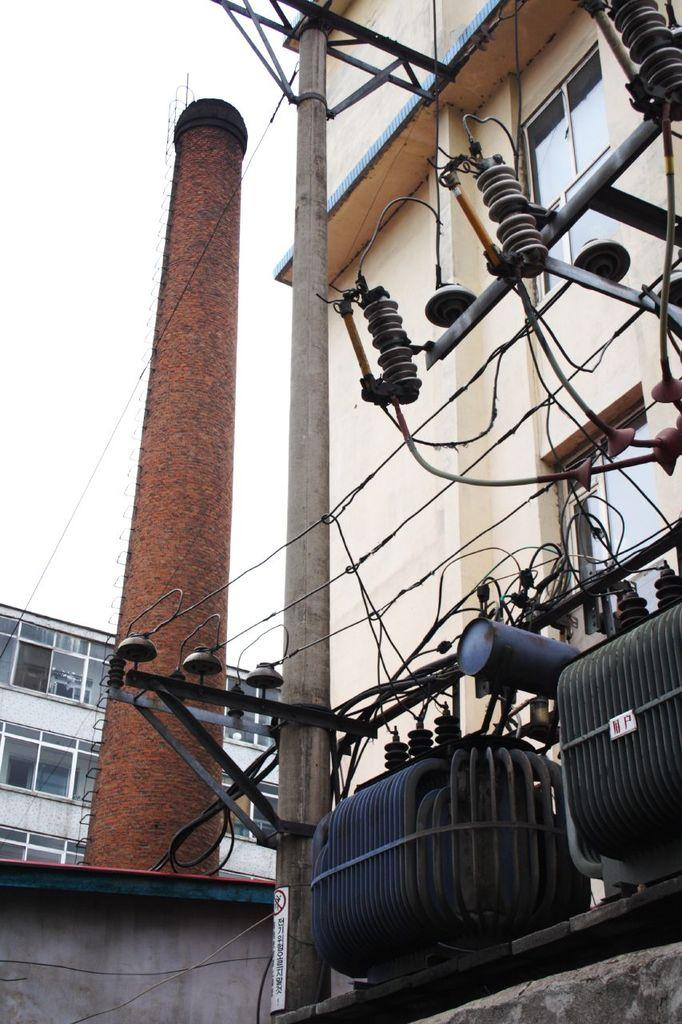What type of electrical equipment can be seen in the image? There are transformers in the image. What else can be seen in the image besides the transformers? There are poles and wires visible in the image. What can be seen in the background of the image? There are buildings, windows, and a wall in the background of the image. What is visible at the top of the image? The sky is visible at the top of the image. What type of fowl is sitting on the transformer in the image? There are no fowl present in the image; it only features transformers, poles, and wires. What rule does the grandfather enforce in the image? There is no grandfather or rule mentioned in the image; it focuses on electrical equipment and infrastructure. 